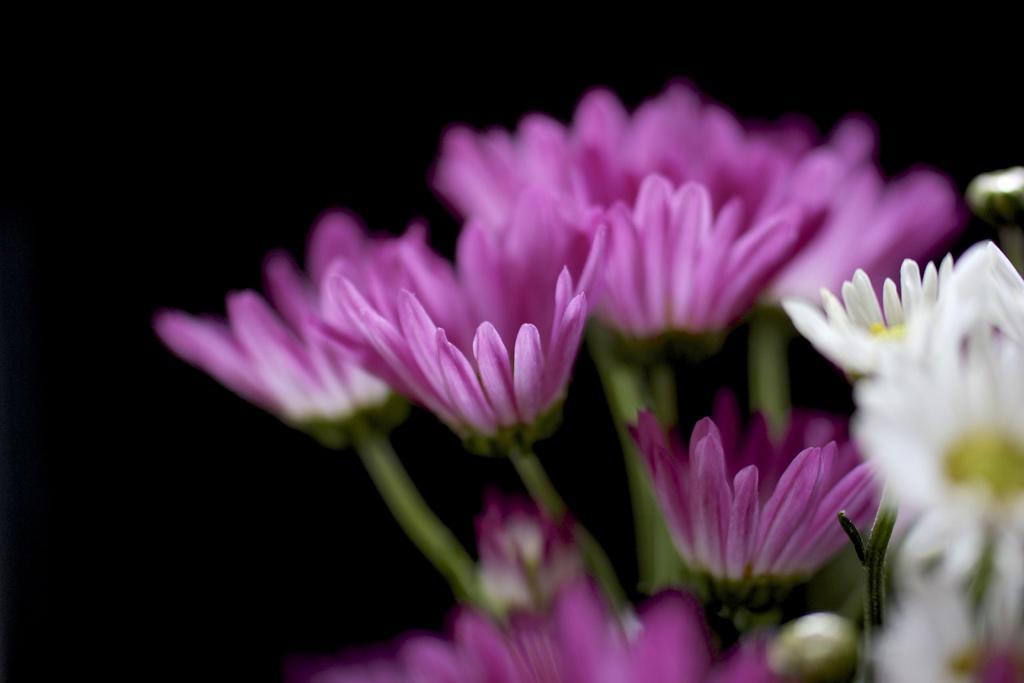In one or two sentences, can you explain what this image depicts? In the picture we can see some flowers which are purple and some are white in color. 